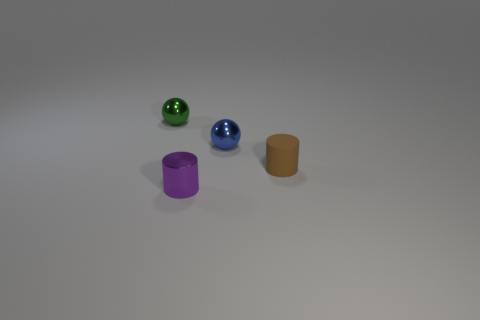Is the material of the small purple cylinder the same as the small sphere on the right side of the tiny purple cylinder? Yes, both the small purple cylinder and the small sphere to its right appear to have a similar glossy finish and reflect light in a comparable way, suggesting that their materials are indeed the same. 